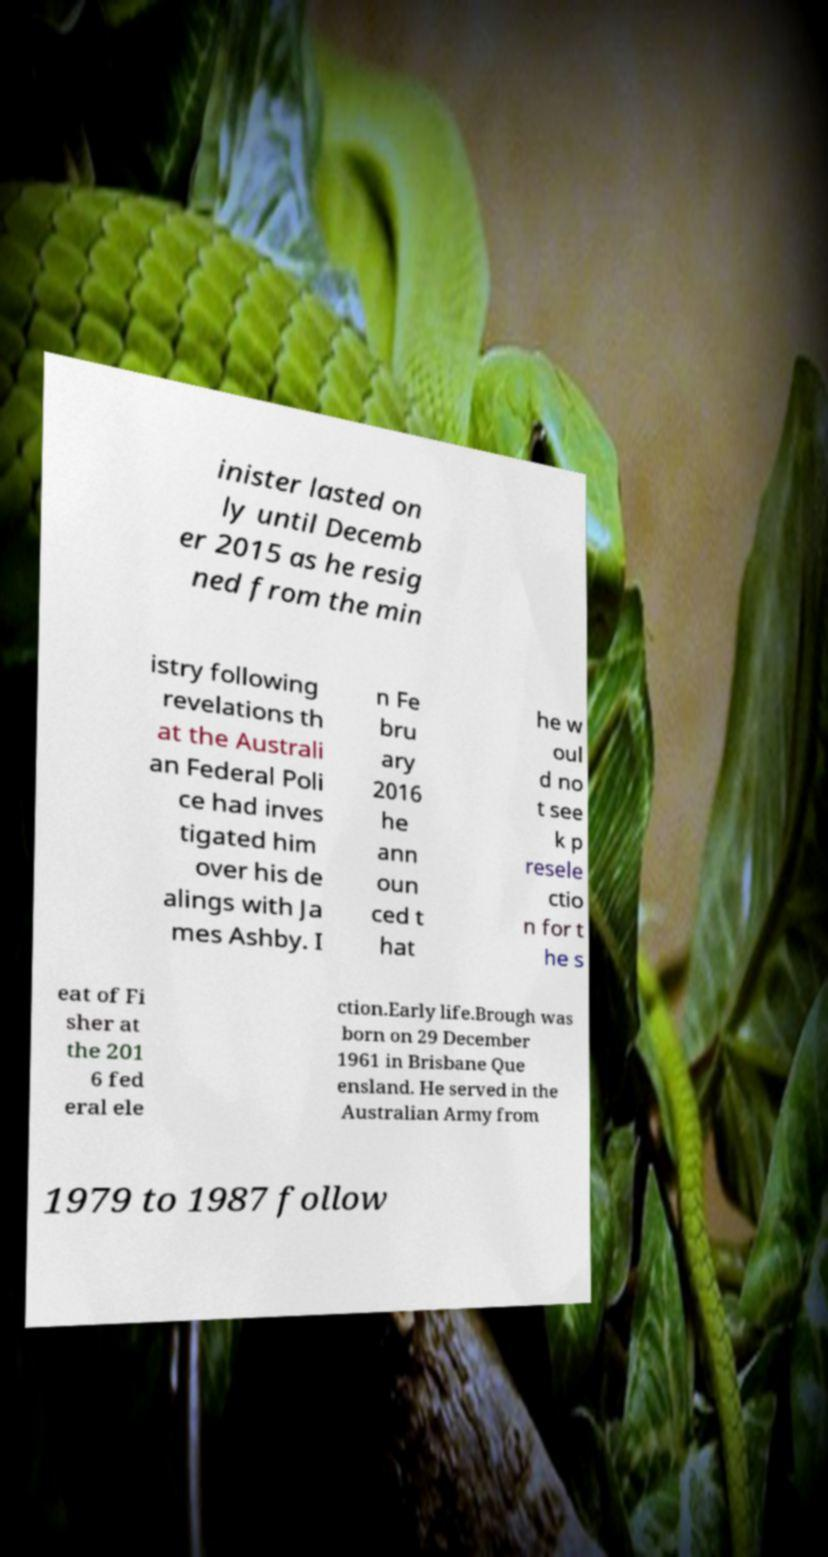For documentation purposes, I need the text within this image transcribed. Could you provide that? inister lasted on ly until Decemb er 2015 as he resig ned from the min istry following revelations th at the Australi an Federal Poli ce had inves tigated him over his de alings with Ja mes Ashby. I n Fe bru ary 2016 he ann oun ced t hat he w oul d no t see k p resele ctio n for t he s eat of Fi sher at the 201 6 fed eral ele ction.Early life.Brough was born on 29 December 1961 in Brisbane Que ensland. He served in the Australian Army from 1979 to 1987 follow 